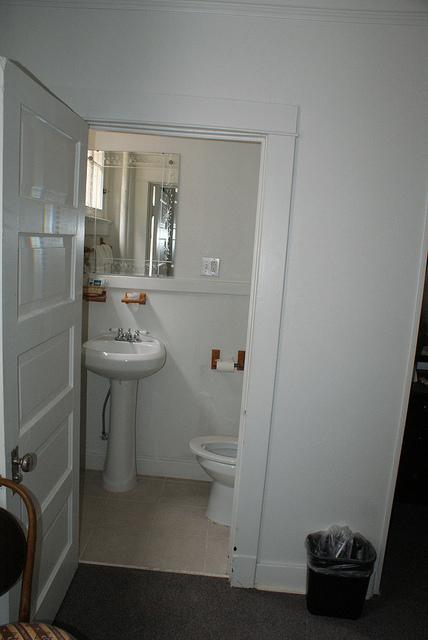What type of flooring is in this room?
Give a very brief answer. Tile. How many urinals are shown?
Write a very short answer. 0. Is this a public toilet?
Answer briefly. No. How many doors are open?
Quick response, please. 1. Is this a typical American bathroom?
Be succinct. Yes. Where does this door lead to?
Short answer required. Bathroom. What color is the trash can?
Quick response, please. Black. Would someone with claustrophobia feel comfortable in this room?
Give a very brief answer. No. How many pets are there?
Quick response, please. 0. Is there any doors in the image?
Short answer required. Yes. Is there a person visible in the mirror?
Quick response, please. No. Is this a bathroom in someone's home?
Concise answer only. Yes. What room is this?
Concise answer only. Bathroom. Is there a baseboard heater?
Short answer required. No. How many mirrors are there?
Be succinct. 1. Does the bathroom need to be refurbished?
Quick response, please. No. What room is?
Concise answer only. Bathroom. What color is the towel rack?
Concise answer only. White. Is this a home bathroom?
Quick response, please. Yes. Are there any plants in the bathroom?
Quick response, please. No. Are there handles for people to steady themselves with?
Answer briefly. No. Why are there items on the self?
Answer briefly. There is no shelf in this photo. How many rolls of toilet paper is there?
Quick response, please. 1. Do any children live in this home?
Quick response, please. No. Is there paper on the roll?
Quick response, please. Yes. Is there a blow dryer hanging on the wall?
Answer briefly. No. What room was this picture taken in?
Give a very brief answer. Bathroom. What shape are the mirrors?
Be succinct. Rectangle. Is the door fully open?
Give a very brief answer. Yes. What is the trash can made of?
Short answer required. Plastic. How many sinks are in the bathroom?
Concise answer only. 1. Is there a trash can in this room?
Short answer required. Yes. What color is the bin on the floor?
Write a very short answer. Black. Does this bathroom have a shower?
Answer briefly. No. Is there a walk in shower?
Quick response, please. No. How large is the space?
Quick response, please. Small. Do these people take out the trash frequently?
Short answer required. Yes. 